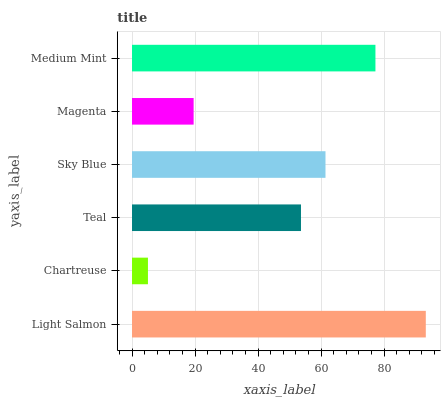Is Chartreuse the minimum?
Answer yes or no. Yes. Is Light Salmon the maximum?
Answer yes or no. Yes. Is Teal the minimum?
Answer yes or no. No. Is Teal the maximum?
Answer yes or no. No. Is Teal greater than Chartreuse?
Answer yes or no. Yes. Is Chartreuse less than Teal?
Answer yes or no. Yes. Is Chartreuse greater than Teal?
Answer yes or no. No. Is Teal less than Chartreuse?
Answer yes or no. No. Is Sky Blue the high median?
Answer yes or no. Yes. Is Teal the low median?
Answer yes or no. Yes. Is Medium Mint the high median?
Answer yes or no. No. Is Sky Blue the low median?
Answer yes or no. No. 